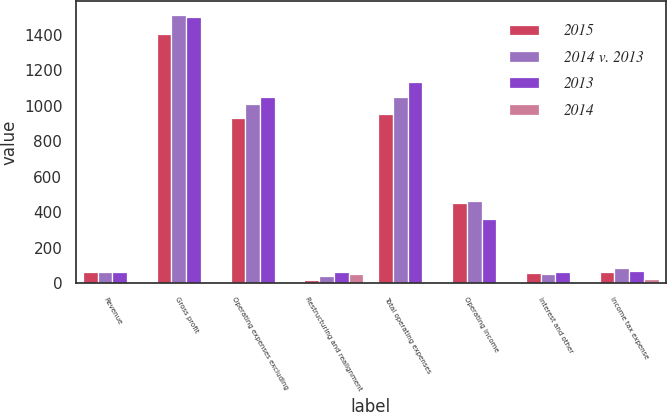<chart> <loc_0><loc_0><loc_500><loc_500><stacked_bar_chart><ecel><fcel>Revenue<fcel>Gross profit<fcel>Operating expenses excluding<fcel>Restructuring and realignment<fcel>Total operating expenses<fcel>Operating income<fcel>Interest and other<fcel>Income tax expense<nl><fcel>2015<fcel>65<fcel>1404<fcel>930<fcel>20<fcel>955<fcel>449<fcel>55<fcel>63<nl><fcel>2014 v. 2013<fcel>65<fcel>1513<fcel>1007<fcel>43<fcel>1050<fcel>463<fcel>53<fcel>84<nl><fcel>2013<fcel>65<fcel>1499<fcel>1048<fcel>64<fcel>1136<fcel>363<fcel>65<fcel>70<nl><fcel>2014<fcel>6.7<fcel>7.2<fcel>7.6<fcel>53.5<fcel>9<fcel>3<fcel>3.8<fcel>25<nl></chart> 